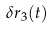<formula> <loc_0><loc_0><loc_500><loc_500>\delta r _ { 3 } ( t )</formula> 